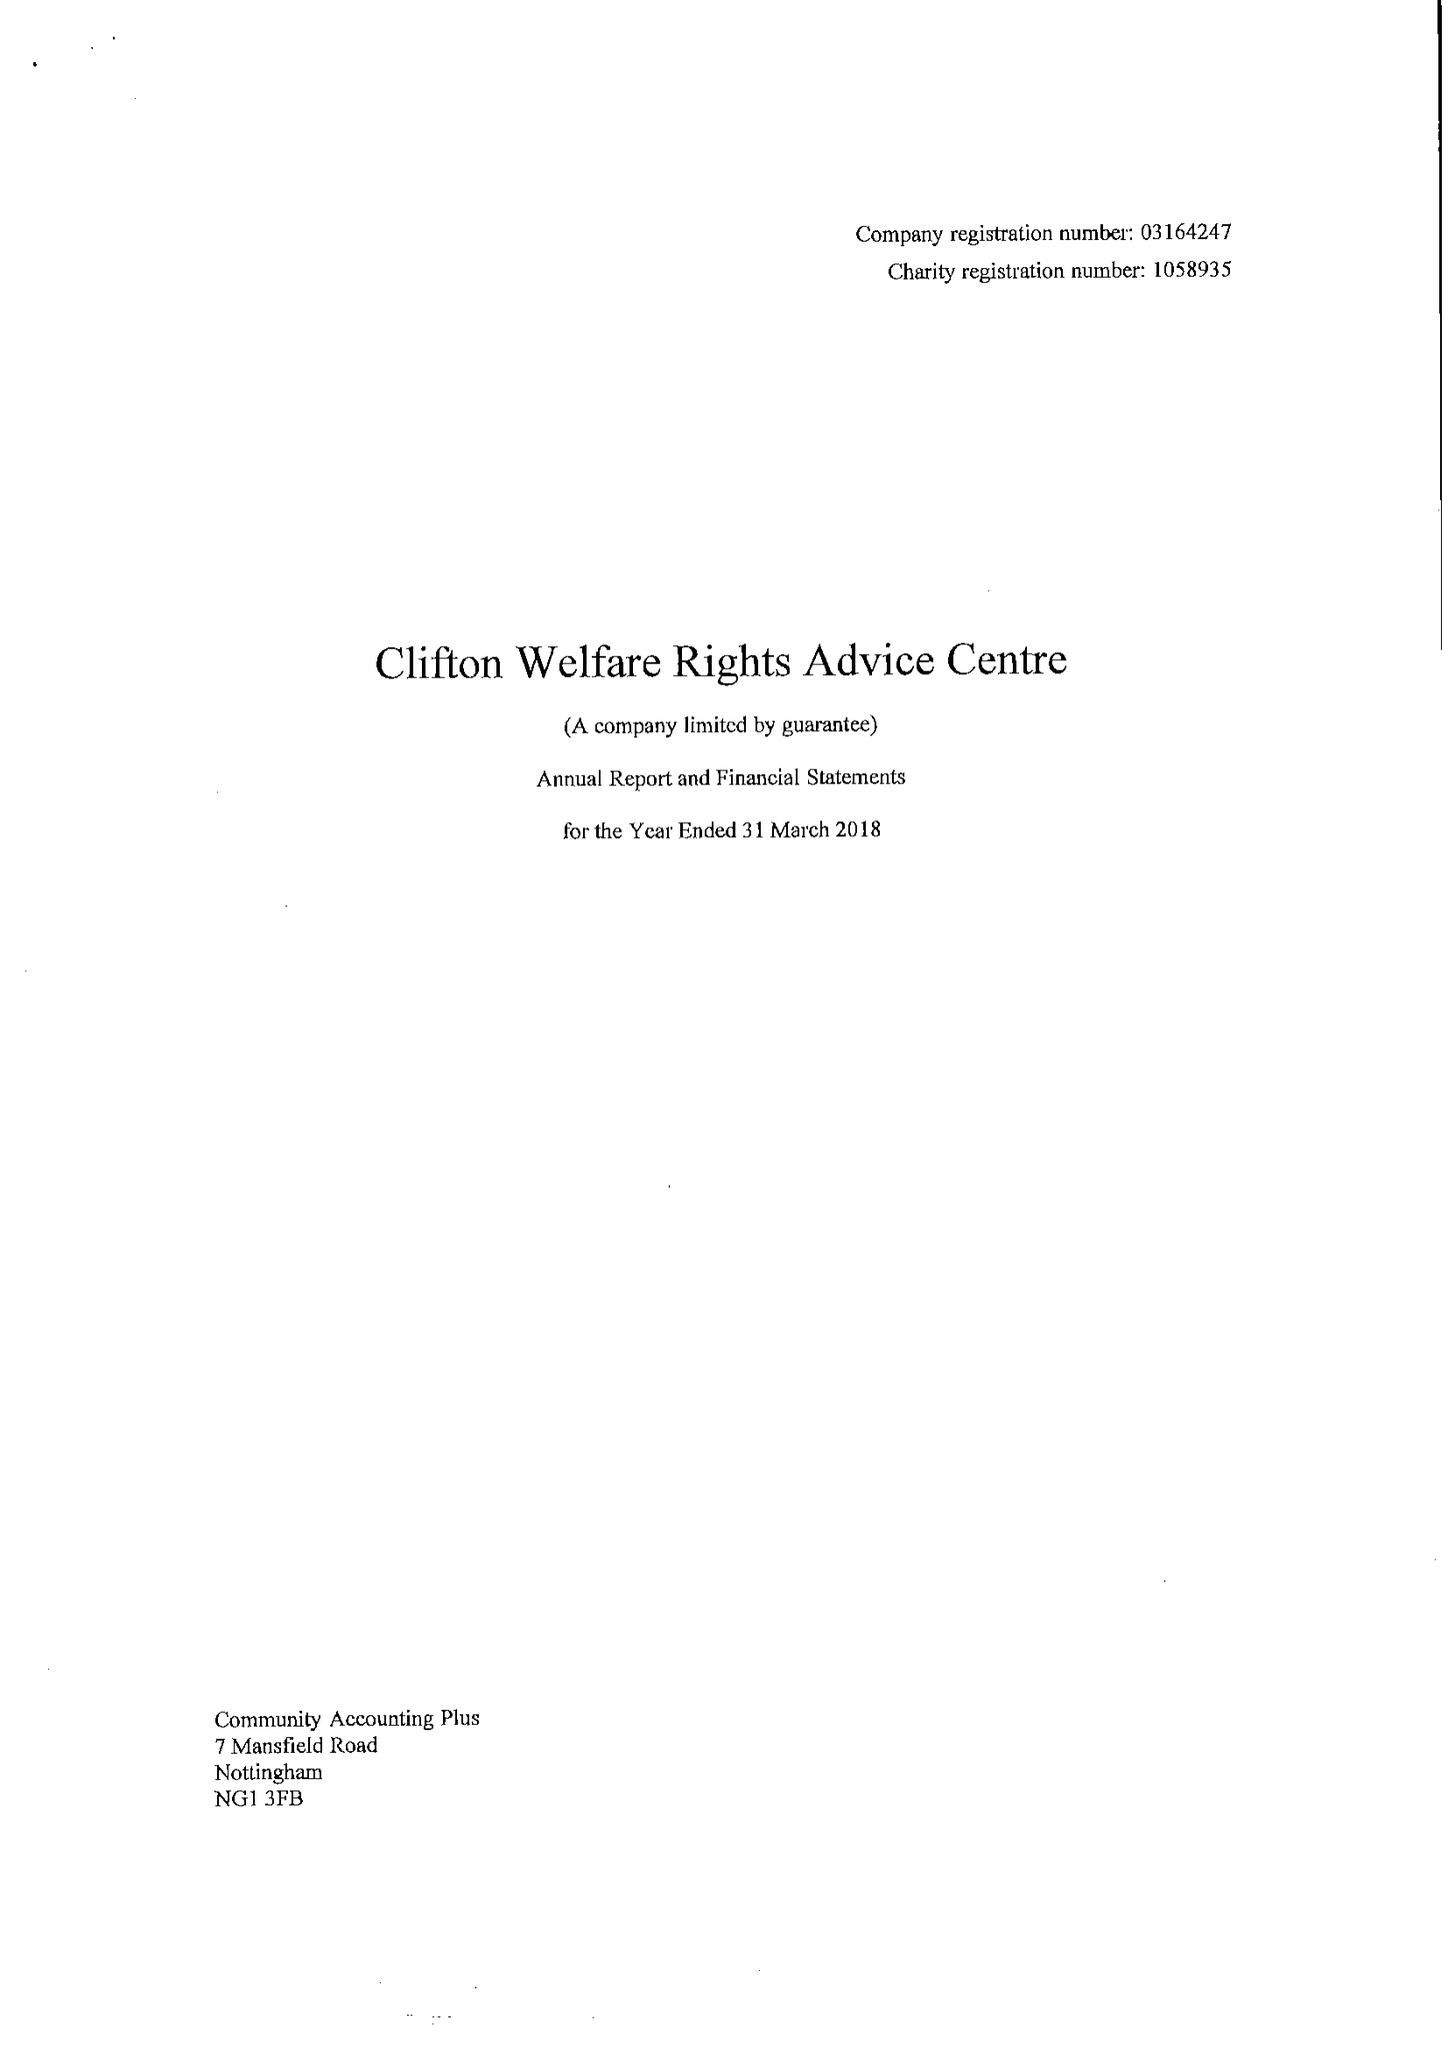What is the value for the charity_name?
Answer the question using a single word or phrase. Clifton Welfare Rights Advice Centre 